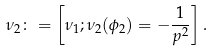Convert formula to latex. <formula><loc_0><loc_0><loc_500><loc_500>\nu _ { 2 } \colon = \left [ \nu _ { 1 } ; \nu _ { 2 } ( \phi _ { 2 } ) = - \frac { 1 } { p ^ { 2 } } \right ] .</formula> 